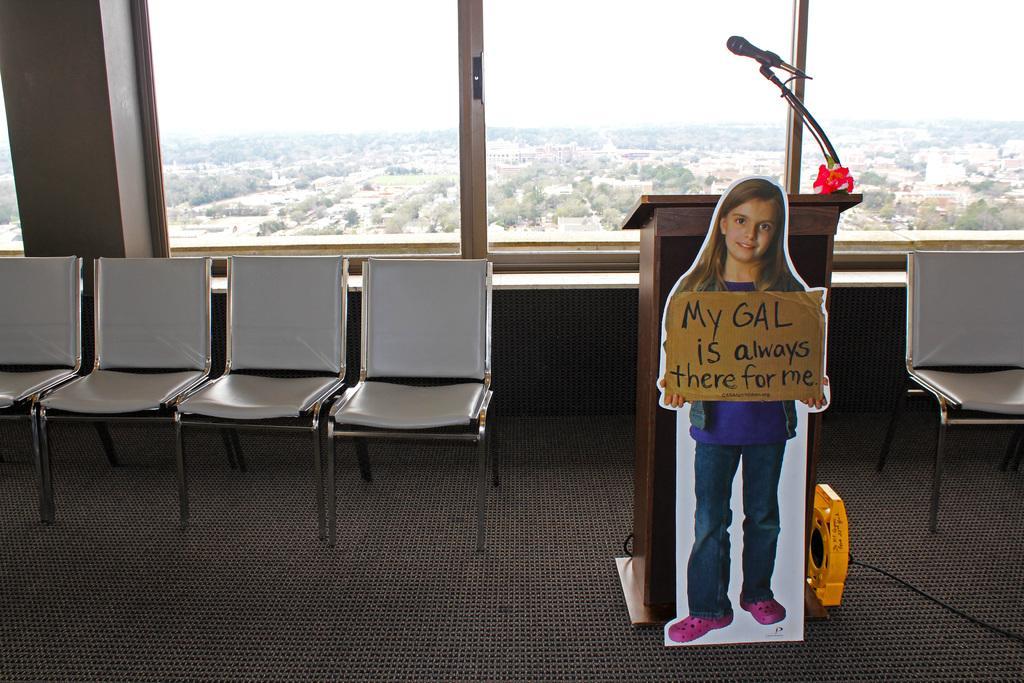Can you describe this image briefly? In this image, we can see wooden podium and banner. In this banner, we can see a girl is holding a board. There is something that is written on it. At the bottom, there is a floor. Here we can see chairs, microphone, rod, windows, pillar. Through the glass we can see the outside view. There are so many trees, houses and sky.  